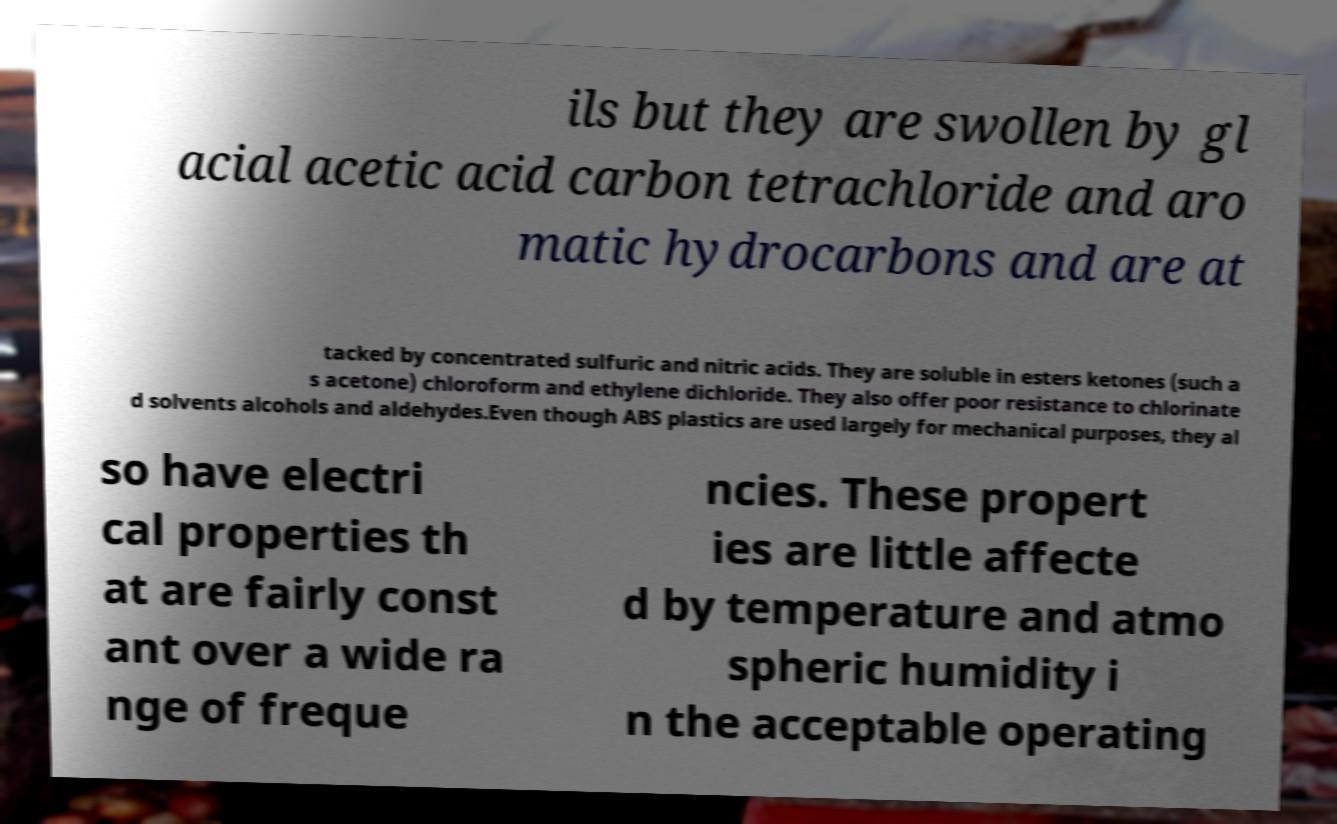For documentation purposes, I need the text within this image transcribed. Could you provide that? ils but they are swollen by gl acial acetic acid carbon tetrachloride and aro matic hydrocarbons and are at tacked by concentrated sulfuric and nitric acids. They are soluble in esters ketones (such a s acetone) chloroform and ethylene dichloride. They also offer poor resistance to chlorinate d solvents alcohols and aldehydes.Even though ABS plastics are used largely for mechanical purposes, they al so have electri cal properties th at are fairly const ant over a wide ra nge of freque ncies. These propert ies are little affecte d by temperature and atmo spheric humidity i n the acceptable operating 